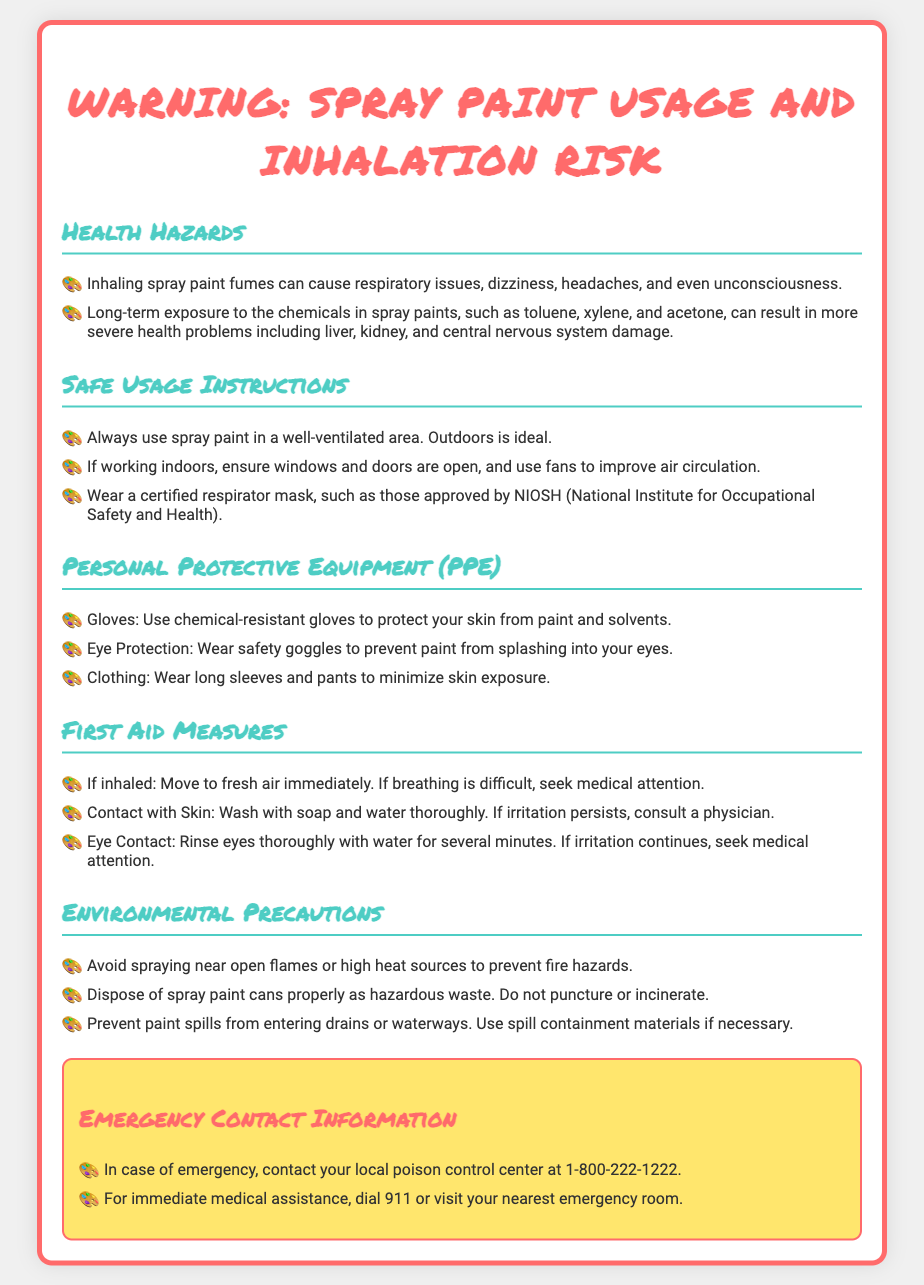what can inhaling spray paint fumes cause? The document lists several health hazards associated with inhaling spray paint fumes, including respiratory issues, dizziness, headaches, and even unconsciousness.
Answer: respiratory issues, dizziness, headaches, unconsciousness what should you wear for eye protection? The document specifies wearing safety goggles to prevent paint from splashing into your eyes.
Answer: safety goggles what is the emergency contact for poison control? The emergency contact information states to contact your local poison control center at the specific number provided.
Answer: 1-800-222-1222 what is recommended for ventilation while using spray paint? The document emphasizes the importance of using spray paint in a well-ventilated area and suggests that outdoors is ideal.
Answer: well-ventilated area what should you do if spray paint is inhaled? The document outlines steps to take if spray paint is inhaled, particularly moving to fresh air immediately.
Answer: Move to fresh air immediately how should spray paint cans be disposed of? The environmental precautions section advises to dispose of spray paint cans properly as hazardous waste.
Answer: as hazardous waste what should you do in case of skin contact with spray paint? The first aid measures section indicates washing the affected area with soap and water thoroughly if there is contact with skin.
Answer: Wash with soap and water thoroughly why should you avoid spraying near flames? The document warns against spraying near flames or high heat sources to prevent fire hazards.
Answer: prevent fire hazards 